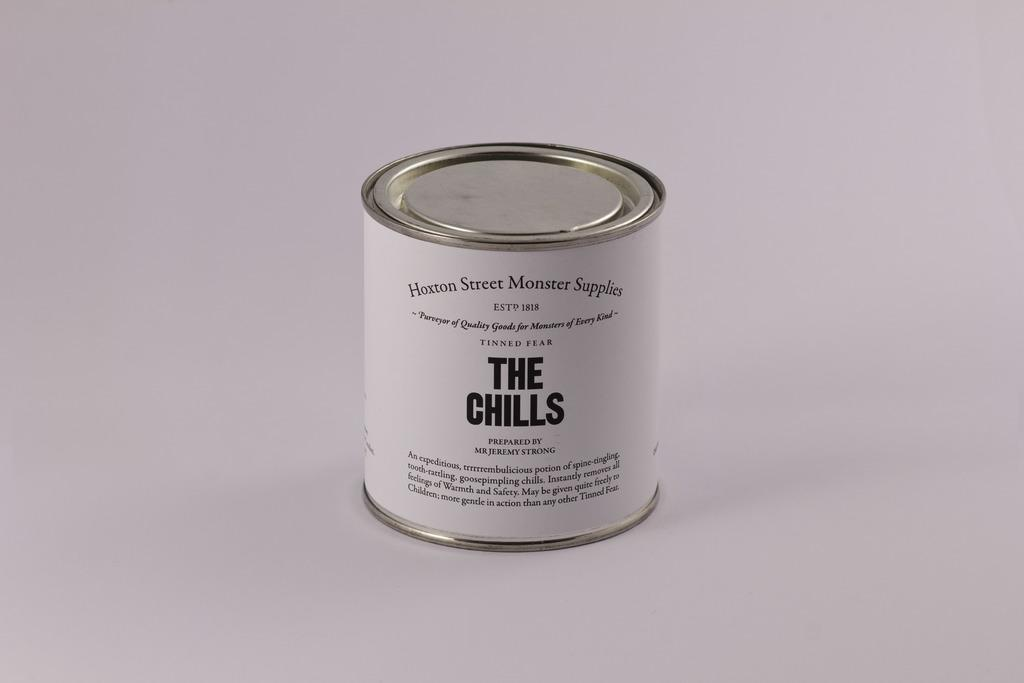<image>
Share a concise interpretation of the image provided. White can of the chills from Hoxton street monster supplies 